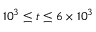<formula> <loc_0><loc_0><loc_500><loc_500>1 0 ^ { 3 } \leq t \leq 6 \times 1 0 ^ { 3 }</formula> 